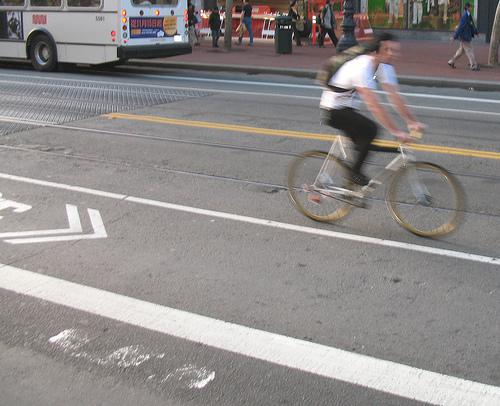Question: how many people are biking?
Choices:
A. 1.
B. 2.
C. 3.
D. 4.
Answer with the letter. Answer: A Question: when was the pic taken?
Choices:
A. At a party.
B. At 6 am.
C. During the day.
D. During the thunderstorm.
Answer with the letter. Answer: C Question: what is the man doing?
Choices:
A. Reading a book.
B. Writing in his notebook.
C. Talking on the phone.
D. Riding a bike.
Answer with the letter. Answer: D Question: what is behind him?
Choices:
A. A cow.
B. A mud hole.
C. A tiger.
D. A bus.
Answer with the letter. Answer: D 